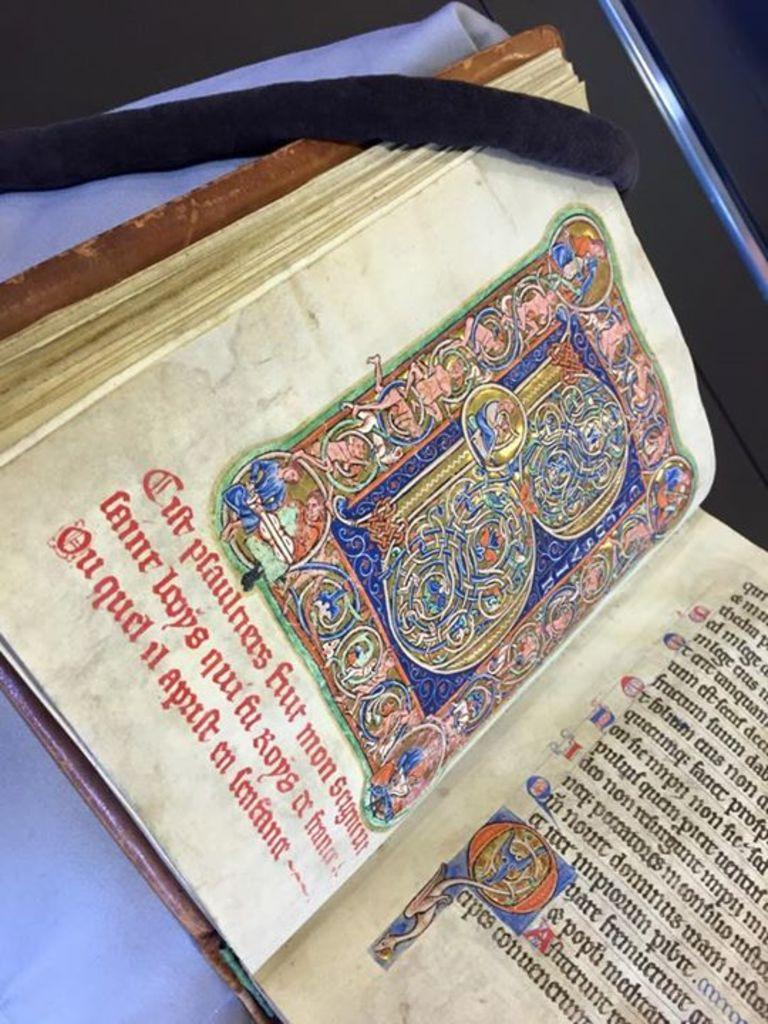<image>
Give a short and clear explanation of the subsequent image. An old manuscript book open on an ornate letter B with the word mon in the text 